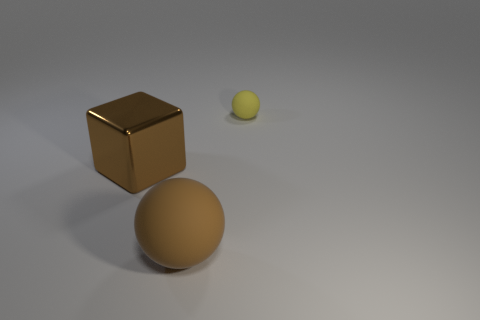Subtract all brown balls. How many balls are left? 1 Add 1 small yellow rubber objects. How many objects exist? 4 Add 3 yellow rubber spheres. How many yellow rubber spheres are left? 4 Add 3 small yellow shiny cylinders. How many small yellow shiny cylinders exist? 3 Subtract 0 yellow cubes. How many objects are left? 3 Subtract all spheres. How many objects are left? 1 Subtract all red blocks. Subtract all purple cylinders. How many blocks are left? 1 Subtract all yellow metal cylinders. Subtract all big brown objects. How many objects are left? 1 